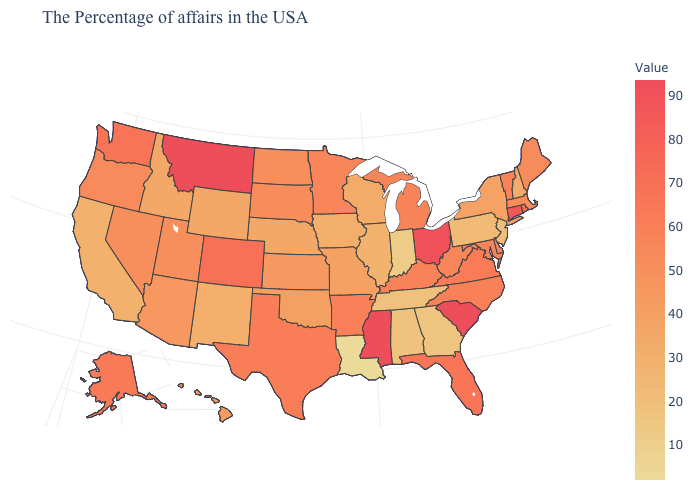Does Montana have a higher value than Alaska?
Concise answer only. Yes. Among the states that border Kansas , does Nebraska have the highest value?
Give a very brief answer. No. Does the map have missing data?
Give a very brief answer. No. Does South Carolina have the lowest value in the South?
Keep it brief. No. 